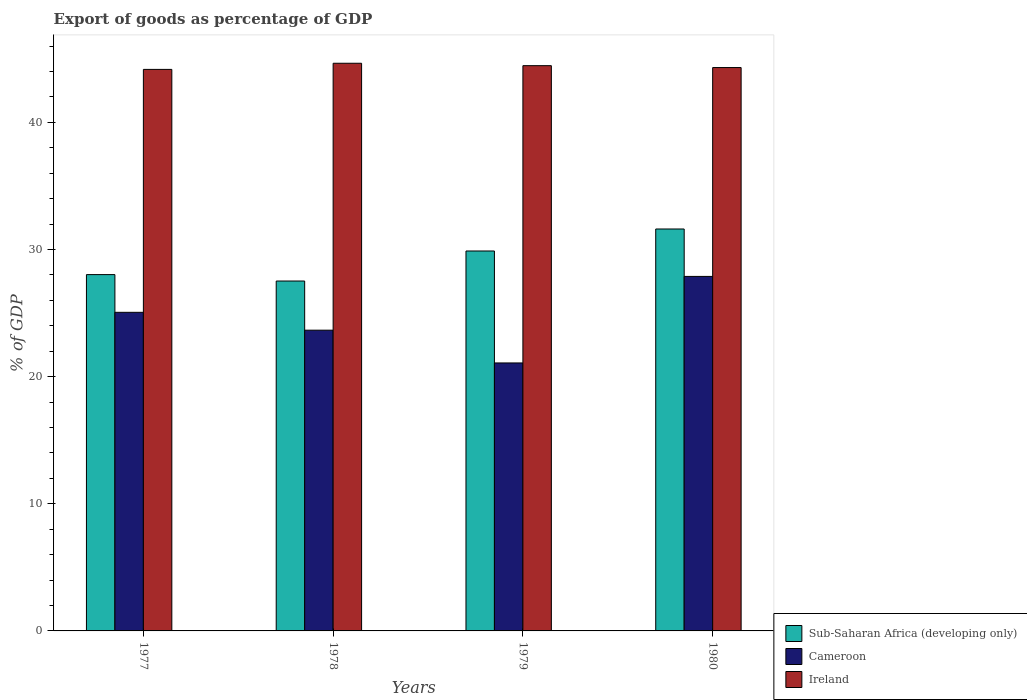How many different coloured bars are there?
Ensure brevity in your answer.  3. How many groups of bars are there?
Your answer should be compact. 4. Are the number of bars per tick equal to the number of legend labels?
Offer a terse response. Yes. Are the number of bars on each tick of the X-axis equal?
Keep it short and to the point. Yes. How many bars are there on the 3rd tick from the left?
Make the answer very short. 3. How many bars are there on the 3rd tick from the right?
Keep it short and to the point. 3. What is the label of the 1st group of bars from the left?
Ensure brevity in your answer.  1977. In how many cases, is the number of bars for a given year not equal to the number of legend labels?
Provide a short and direct response. 0. What is the export of goods as percentage of GDP in Sub-Saharan Africa (developing only) in 1978?
Ensure brevity in your answer.  27.52. Across all years, what is the maximum export of goods as percentage of GDP in Cameroon?
Offer a terse response. 27.88. Across all years, what is the minimum export of goods as percentage of GDP in Sub-Saharan Africa (developing only)?
Your answer should be compact. 27.52. In which year was the export of goods as percentage of GDP in Sub-Saharan Africa (developing only) minimum?
Offer a very short reply. 1978. What is the total export of goods as percentage of GDP in Ireland in the graph?
Provide a succinct answer. 177.59. What is the difference between the export of goods as percentage of GDP in Cameroon in 1977 and that in 1979?
Your answer should be compact. 3.98. What is the difference between the export of goods as percentage of GDP in Sub-Saharan Africa (developing only) in 1979 and the export of goods as percentage of GDP in Ireland in 1980?
Your answer should be compact. -14.43. What is the average export of goods as percentage of GDP in Sub-Saharan Africa (developing only) per year?
Make the answer very short. 29.26. In the year 1980, what is the difference between the export of goods as percentage of GDP in Cameroon and export of goods as percentage of GDP in Sub-Saharan Africa (developing only)?
Offer a very short reply. -3.73. In how many years, is the export of goods as percentage of GDP in Ireland greater than 38 %?
Your answer should be compact. 4. What is the ratio of the export of goods as percentage of GDP in Sub-Saharan Africa (developing only) in 1977 to that in 1980?
Provide a short and direct response. 0.89. Is the difference between the export of goods as percentage of GDP in Cameroon in 1978 and 1980 greater than the difference between the export of goods as percentage of GDP in Sub-Saharan Africa (developing only) in 1978 and 1980?
Your answer should be very brief. No. What is the difference between the highest and the second highest export of goods as percentage of GDP in Cameroon?
Your answer should be compact. 2.82. What is the difference between the highest and the lowest export of goods as percentage of GDP in Ireland?
Provide a succinct answer. 0.48. Is the sum of the export of goods as percentage of GDP in Sub-Saharan Africa (developing only) in 1978 and 1979 greater than the maximum export of goods as percentage of GDP in Cameroon across all years?
Your answer should be very brief. Yes. What does the 3rd bar from the left in 1980 represents?
Make the answer very short. Ireland. What does the 3rd bar from the right in 1978 represents?
Offer a terse response. Sub-Saharan Africa (developing only). Are all the bars in the graph horizontal?
Your answer should be compact. No. How many years are there in the graph?
Make the answer very short. 4. How are the legend labels stacked?
Your answer should be compact. Vertical. What is the title of the graph?
Offer a terse response. Export of goods as percentage of GDP. What is the label or title of the X-axis?
Provide a succinct answer. Years. What is the label or title of the Y-axis?
Make the answer very short. % of GDP. What is the % of GDP in Sub-Saharan Africa (developing only) in 1977?
Your answer should be very brief. 28.03. What is the % of GDP of Cameroon in 1977?
Offer a terse response. 25.06. What is the % of GDP of Ireland in 1977?
Provide a short and direct response. 44.17. What is the % of GDP in Sub-Saharan Africa (developing only) in 1978?
Your answer should be very brief. 27.52. What is the % of GDP in Cameroon in 1978?
Give a very brief answer. 23.66. What is the % of GDP of Ireland in 1978?
Offer a terse response. 44.65. What is the % of GDP of Sub-Saharan Africa (developing only) in 1979?
Your answer should be compact. 29.88. What is the % of GDP of Cameroon in 1979?
Provide a succinct answer. 21.08. What is the % of GDP of Ireland in 1979?
Provide a short and direct response. 44.46. What is the % of GDP of Sub-Saharan Africa (developing only) in 1980?
Your answer should be compact. 31.61. What is the % of GDP of Cameroon in 1980?
Offer a terse response. 27.88. What is the % of GDP in Ireland in 1980?
Make the answer very short. 44.31. Across all years, what is the maximum % of GDP in Sub-Saharan Africa (developing only)?
Provide a succinct answer. 31.61. Across all years, what is the maximum % of GDP of Cameroon?
Make the answer very short. 27.88. Across all years, what is the maximum % of GDP of Ireland?
Make the answer very short. 44.65. Across all years, what is the minimum % of GDP in Sub-Saharan Africa (developing only)?
Make the answer very short. 27.52. Across all years, what is the minimum % of GDP of Cameroon?
Offer a terse response. 21.08. Across all years, what is the minimum % of GDP in Ireland?
Ensure brevity in your answer.  44.17. What is the total % of GDP of Sub-Saharan Africa (developing only) in the graph?
Give a very brief answer. 117.05. What is the total % of GDP of Cameroon in the graph?
Your answer should be compact. 97.68. What is the total % of GDP in Ireland in the graph?
Make the answer very short. 177.59. What is the difference between the % of GDP of Sub-Saharan Africa (developing only) in 1977 and that in 1978?
Your answer should be very brief. 0.51. What is the difference between the % of GDP of Cameroon in 1977 and that in 1978?
Offer a terse response. 1.4. What is the difference between the % of GDP of Ireland in 1977 and that in 1978?
Keep it short and to the point. -0.48. What is the difference between the % of GDP in Sub-Saharan Africa (developing only) in 1977 and that in 1979?
Ensure brevity in your answer.  -1.86. What is the difference between the % of GDP of Cameroon in 1977 and that in 1979?
Offer a terse response. 3.98. What is the difference between the % of GDP in Ireland in 1977 and that in 1979?
Offer a terse response. -0.29. What is the difference between the % of GDP of Sub-Saharan Africa (developing only) in 1977 and that in 1980?
Your response must be concise. -3.59. What is the difference between the % of GDP of Cameroon in 1977 and that in 1980?
Ensure brevity in your answer.  -2.82. What is the difference between the % of GDP in Ireland in 1977 and that in 1980?
Provide a succinct answer. -0.15. What is the difference between the % of GDP in Sub-Saharan Africa (developing only) in 1978 and that in 1979?
Give a very brief answer. -2.36. What is the difference between the % of GDP in Cameroon in 1978 and that in 1979?
Provide a succinct answer. 2.58. What is the difference between the % of GDP in Ireland in 1978 and that in 1979?
Ensure brevity in your answer.  0.19. What is the difference between the % of GDP in Sub-Saharan Africa (developing only) in 1978 and that in 1980?
Your answer should be very brief. -4.09. What is the difference between the % of GDP of Cameroon in 1978 and that in 1980?
Keep it short and to the point. -4.23. What is the difference between the % of GDP of Ireland in 1978 and that in 1980?
Your answer should be very brief. 0.34. What is the difference between the % of GDP in Sub-Saharan Africa (developing only) in 1979 and that in 1980?
Your response must be concise. -1.73. What is the difference between the % of GDP of Cameroon in 1979 and that in 1980?
Offer a very short reply. -6.81. What is the difference between the % of GDP in Ireland in 1979 and that in 1980?
Provide a succinct answer. 0.15. What is the difference between the % of GDP of Sub-Saharan Africa (developing only) in 1977 and the % of GDP of Cameroon in 1978?
Your response must be concise. 4.37. What is the difference between the % of GDP of Sub-Saharan Africa (developing only) in 1977 and the % of GDP of Ireland in 1978?
Your answer should be very brief. -16.62. What is the difference between the % of GDP in Cameroon in 1977 and the % of GDP in Ireland in 1978?
Give a very brief answer. -19.59. What is the difference between the % of GDP in Sub-Saharan Africa (developing only) in 1977 and the % of GDP in Cameroon in 1979?
Your response must be concise. 6.95. What is the difference between the % of GDP in Sub-Saharan Africa (developing only) in 1977 and the % of GDP in Ireland in 1979?
Offer a terse response. -16.43. What is the difference between the % of GDP in Cameroon in 1977 and the % of GDP in Ireland in 1979?
Ensure brevity in your answer.  -19.4. What is the difference between the % of GDP in Sub-Saharan Africa (developing only) in 1977 and the % of GDP in Cameroon in 1980?
Your answer should be very brief. 0.14. What is the difference between the % of GDP in Sub-Saharan Africa (developing only) in 1977 and the % of GDP in Ireland in 1980?
Your answer should be very brief. -16.29. What is the difference between the % of GDP of Cameroon in 1977 and the % of GDP of Ireland in 1980?
Your response must be concise. -19.25. What is the difference between the % of GDP of Sub-Saharan Africa (developing only) in 1978 and the % of GDP of Cameroon in 1979?
Provide a succinct answer. 6.44. What is the difference between the % of GDP in Sub-Saharan Africa (developing only) in 1978 and the % of GDP in Ireland in 1979?
Your answer should be compact. -16.94. What is the difference between the % of GDP of Cameroon in 1978 and the % of GDP of Ireland in 1979?
Provide a succinct answer. -20.81. What is the difference between the % of GDP in Sub-Saharan Africa (developing only) in 1978 and the % of GDP in Cameroon in 1980?
Provide a short and direct response. -0.36. What is the difference between the % of GDP of Sub-Saharan Africa (developing only) in 1978 and the % of GDP of Ireland in 1980?
Ensure brevity in your answer.  -16.79. What is the difference between the % of GDP of Cameroon in 1978 and the % of GDP of Ireland in 1980?
Your answer should be very brief. -20.66. What is the difference between the % of GDP in Sub-Saharan Africa (developing only) in 1979 and the % of GDP in Cameroon in 1980?
Offer a very short reply. 2. What is the difference between the % of GDP in Sub-Saharan Africa (developing only) in 1979 and the % of GDP in Ireland in 1980?
Provide a short and direct response. -14.43. What is the difference between the % of GDP of Cameroon in 1979 and the % of GDP of Ireland in 1980?
Provide a succinct answer. -23.23. What is the average % of GDP of Sub-Saharan Africa (developing only) per year?
Provide a short and direct response. 29.26. What is the average % of GDP of Cameroon per year?
Make the answer very short. 24.42. What is the average % of GDP of Ireland per year?
Give a very brief answer. 44.4. In the year 1977, what is the difference between the % of GDP in Sub-Saharan Africa (developing only) and % of GDP in Cameroon?
Make the answer very short. 2.97. In the year 1977, what is the difference between the % of GDP in Sub-Saharan Africa (developing only) and % of GDP in Ireland?
Offer a terse response. -16.14. In the year 1977, what is the difference between the % of GDP in Cameroon and % of GDP in Ireland?
Your answer should be compact. -19.11. In the year 1978, what is the difference between the % of GDP in Sub-Saharan Africa (developing only) and % of GDP in Cameroon?
Give a very brief answer. 3.87. In the year 1978, what is the difference between the % of GDP in Sub-Saharan Africa (developing only) and % of GDP in Ireland?
Your answer should be compact. -17.13. In the year 1978, what is the difference between the % of GDP in Cameroon and % of GDP in Ireland?
Your answer should be compact. -21. In the year 1979, what is the difference between the % of GDP in Sub-Saharan Africa (developing only) and % of GDP in Cameroon?
Offer a very short reply. 8.81. In the year 1979, what is the difference between the % of GDP of Sub-Saharan Africa (developing only) and % of GDP of Ireland?
Offer a very short reply. -14.58. In the year 1979, what is the difference between the % of GDP in Cameroon and % of GDP in Ireland?
Keep it short and to the point. -23.38. In the year 1980, what is the difference between the % of GDP in Sub-Saharan Africa (developing only) and % of GDP in Cameroon?
Make the answer very short. 3.73. In the year 1980, what is the difference between the % of GDP of Sub-Saharan Africa (developing only) and % of GDP of Ireland?
Your answer should be very brief. -12.7. In the year 1980, what is the difference between the % of GDP of Cameroon and % of GDP of Ireland?
Provide a succinct answer. -16.43. What is the ratio of the % of GDP in Sub-Saharan Africa (developing only) in 1977 to that in 1978?
Your answer should be compact. 1.02. What is the ratio of the % of GDP of Cameroon in 1977 to that in 1978?
Ensure brevity in your answer.  1.06. What is the ratio of the % of GDP of Sub-Saharan Africa (developing only) in 1977 to that in 1979?
Keep it short and to the point. 0.94. What is the ratio of the % of GDP in Cameroon in 1977 to that in 1979?
Make the answer very short. 1.19. What is the ratio of the % of GDP in Sub-Saharan Africa (developing only) in 1977 to that in 1980?
Provide a short and direct response. 0.89. What is the ratio of the % of GDP of Cameroon in 1977 to that in 1980?
Make the answer very short. 0.9. What is the ratio of the % of GDP of Ireland in 1977 to that in 1980?
Offer a very short reply. 1. What is the ratio of the % of GDP in Sub-Saharan Africa (developing only) in 1978 to that in 1979?
Ensure brevity in your answer.  0.92. What is the ratio of the % of GDP in Cameroon in 1978 to that in 1979?
Give a very brief answer. 1.12. What is the ratio of the % of GDP of Sub-Saharan Africa (developing only) in 1978 to that in 1980?
Offer a very short reply. 0.87. What is the ratio of the % of GDP of Cameroon in 1978 to that in 1980?
Offer a very short reply. 0.85. What is the ratio of the % of GDP in Ireland in 1978 to that in 1980?
Your answer should be compact. 1.01. What is the ratio of the % of GDP of Sub-Saharan Africa (developing only) in 1979 to that in 1980?
Your response must be concise. 0.95. What is the ratio of the % of GDP in Cameroon in 1979 to that in 1980?
Give a very brief answer. 0.76. What is the ratio of the % of GDP of Ireland in 1979 to that in 1980?
Keep it short and to the point. 1. What is the difference between the highest and the second highest % of GDP in Sub-Saharan Africa (developing only)?
Provide a succinct answer. 1.73. What is the difference between the highest and the second highest % of GDP in Cameroon?
Give a very brief answer. 2.82. What is the difference between the highest and the second highest % of GDP in Ireland?
Provide a short and direct response. 0.19. What is the difference between the highest and the lowest % of GDP of Sub-Saharan Africa (developing only)?
Offer a terse response. 4.09. What is the difference between the highest and the lowest % of GDP in Cameroon?
Offer a terse response. 6.81. What is the difference between the highest and the lowest % of GDP of Ireland?
Ensure brevity in your answer.  0.48. 